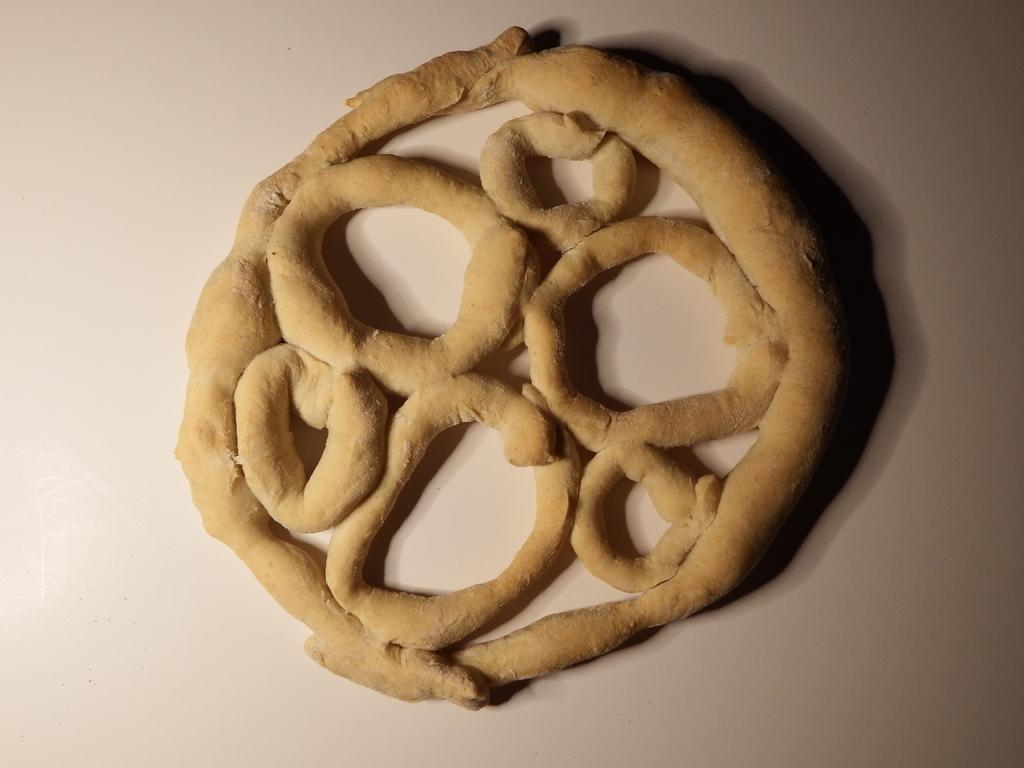What is present in the image? There is food in the image. Where is the food located? The food is on a surface. Is there a horse in the image? No, there is no horse present in the image. 